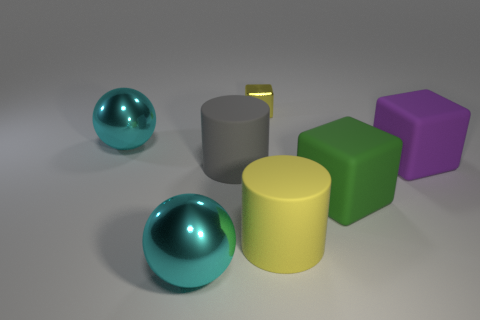Subtract all big rubber blocks. How many blocks are left? 1 Subtract all yellow cylinders. How many cylinders are left? 1 Subtract all blocks. How many objects are left? 4 Subtract 1 balls. How many balls are left? 1 Subtract all brown balls. Subtract all gray cylinders. How many balls are left? 2 Subtract all purple cubes. How many purple spheres are left? 0 Subtract all large gray rubber cylinders. Subtract all small yellow blocks. How many objects are left? 5 Add 3 purple cubes. How many purple cubes are left? 4 Add 5 brown cylinders. How many brown cylinders exist? 5 Add 1 tiny cyan rubber balls. How many objects exist? 8 